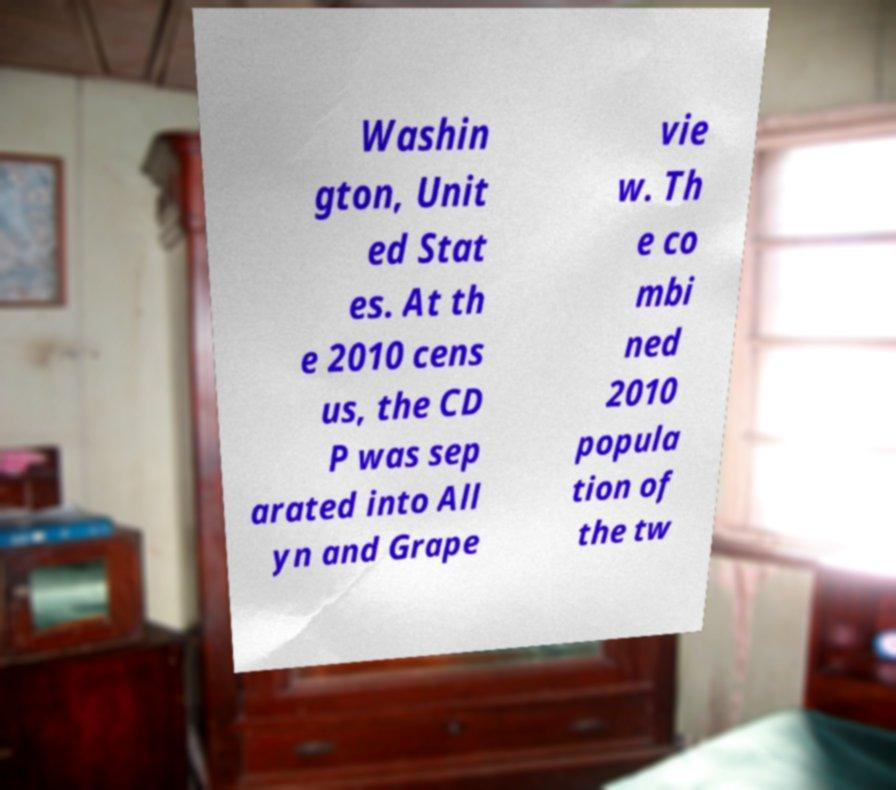I need the written content from this picture converted into text. Can you do that? Washin gton, Unit ed Stat es. At th e 2010 cens us, the CD P was sep arated into All yn and Grape vie w. Th e co mbi ned 2010 popula tion of the tw 